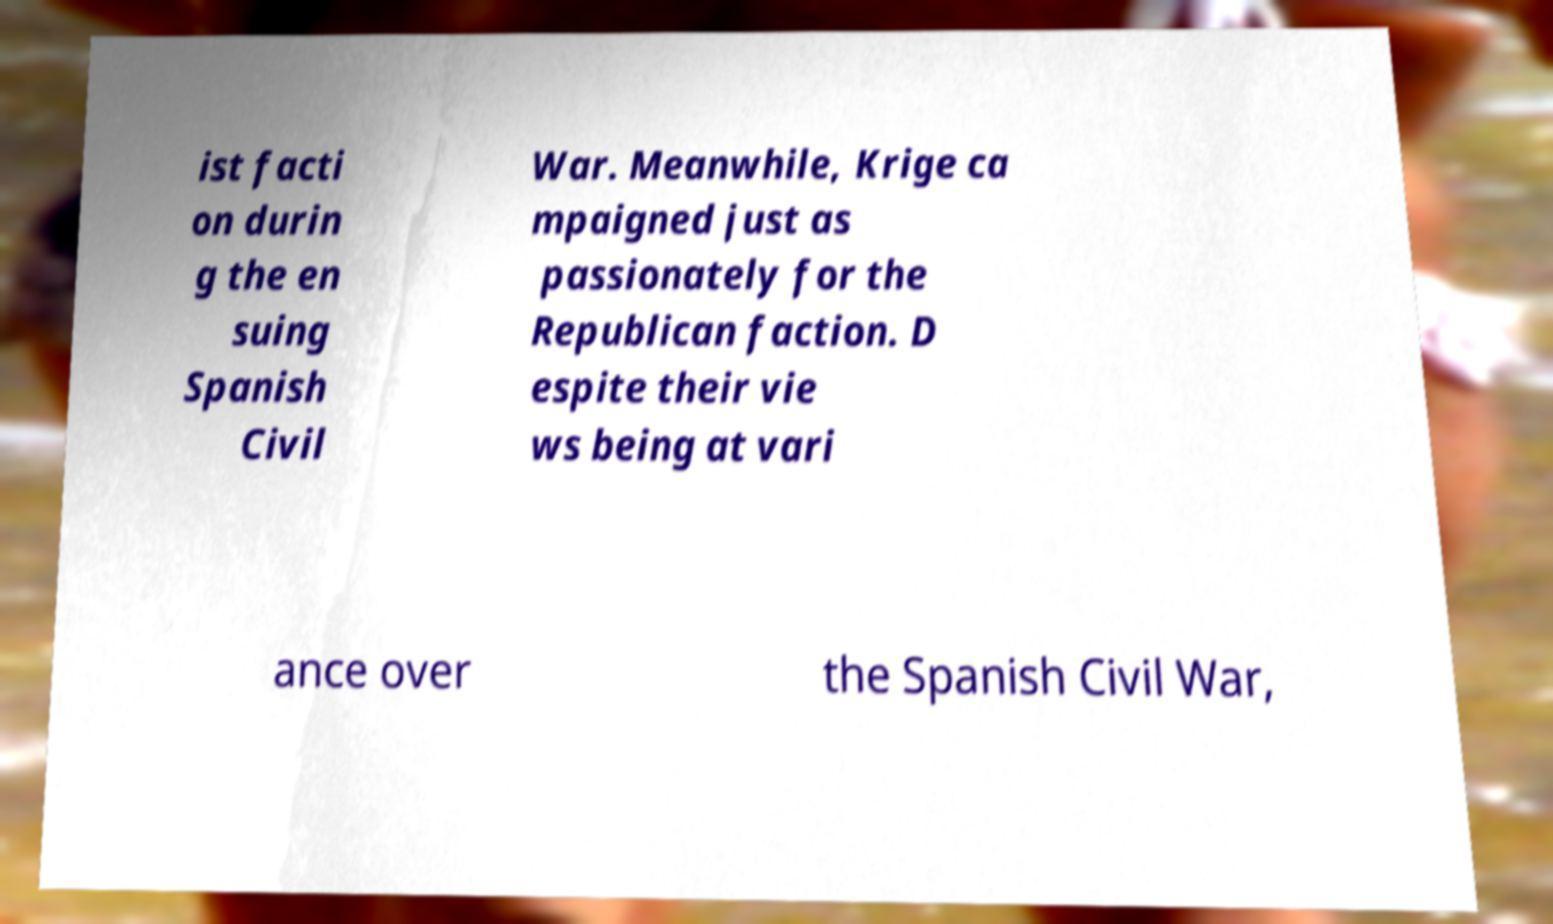Can you accurately transcribe the text from the provided image for me? ist facti on durin g the en suing Spanish Civil War. Meanwhile, Krige ca mpaigned just as passionately for the Republican faction. D espite their vie ws being at vari ance over the Spanish Civil War, 